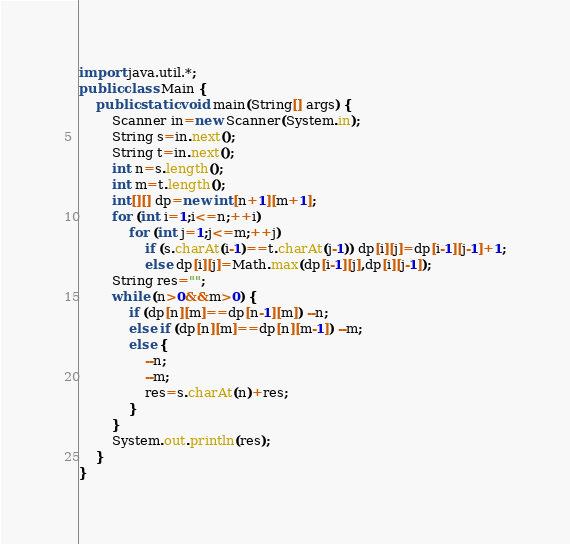Convert code to text. <code><loc_0><loc_0><loc_500><loc_500><_Java_>import java.util.*;
public class Main {
	public static void main(String[] args) {
		Scanner in=new Scanner(System.in);
		String s=in.next();
		String t=in.next();
		int n=s.length();
		int m=t.length();
		int[][] dp=new int[n+1][m+1];
		for (int i=1;i<=n;++i)
			for (int j=1;j<=m;++j)
				if (s.charAt(i-1)==t.charAt(j-1)) dp[i][j]=dp[i-1][j-1]+1;
				else dp[i][j]=Math.max(dp[i-1][j],dp[i][j-1]);
		String res="";
		while (n>0&&m>0) {
			if (dp[n][m]==dp[n-1][m]) --n;
			else if (dp[n][m]==dp[n][m-1]) --m;
			else {
				--n;
				--m;
				res=s.charAt(n)+res;
			}
		}
		System.out.println(res);
	}
}</code> 